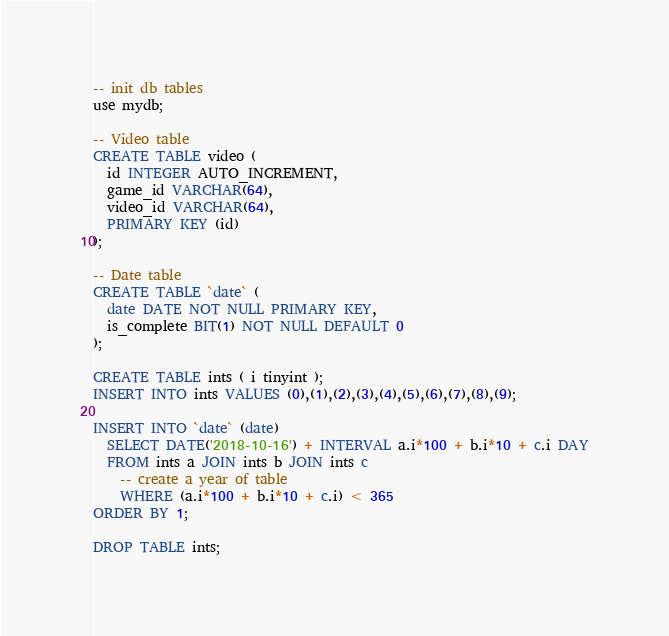<code> <loc_0><loc_0><loc_500><loc_500><_SQL_>-- init db tables
use mydb;

-- Video table
CREATE TABLE video (
  id INTEGER AUTO_INCREMENT,
  game_id VARCHAR(64),
  video_id VARCHAR(64),
  PRIMARY KEY (id)
);

-- Date table
CREATE TABLE `date` (
  date DATE NOT NULL PRIMARY KEY,
  is_complete BIT(1) NOT NULL DEFAULT 0
);

CREATE TABLE ints ( i tinyint );
INSERT INTO ints VALUES (0),(1),(2),(3),(4),(5),(6),(7),(8),(9);

INSERT INTO `date` (date)
  SELECT DATE('2018-10-16') + INTERVAL a.i*100 + b.i*10 + c.i DAY
  FROM ints a JOIN ints b JOIN ints c
    -- create a year of table
    WHERE (a.i*100 + b.i*10 + c.i) < 365
ORDER BY 1;

DROP TABLE ints;
</code> 